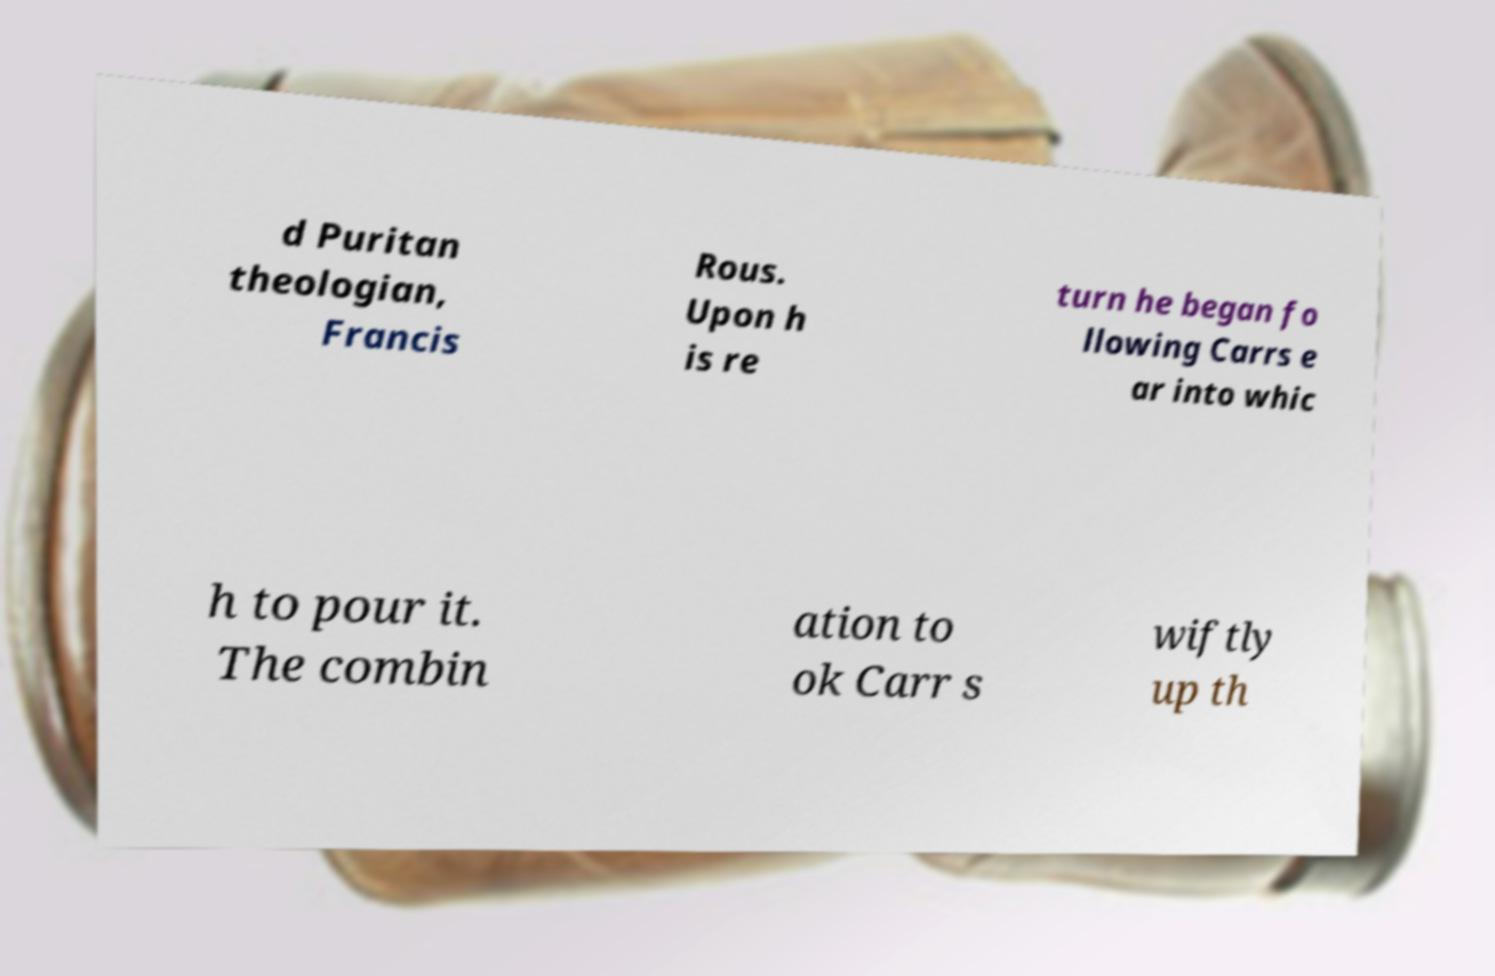Please read and relay the text visible in this image. What does it say? d Puritan theologian, Francis Rous. Upon h is re turn he began fo llowing Carrs e ar into whic h to pour it. The combin ation to ok Carr s wiftly up th 